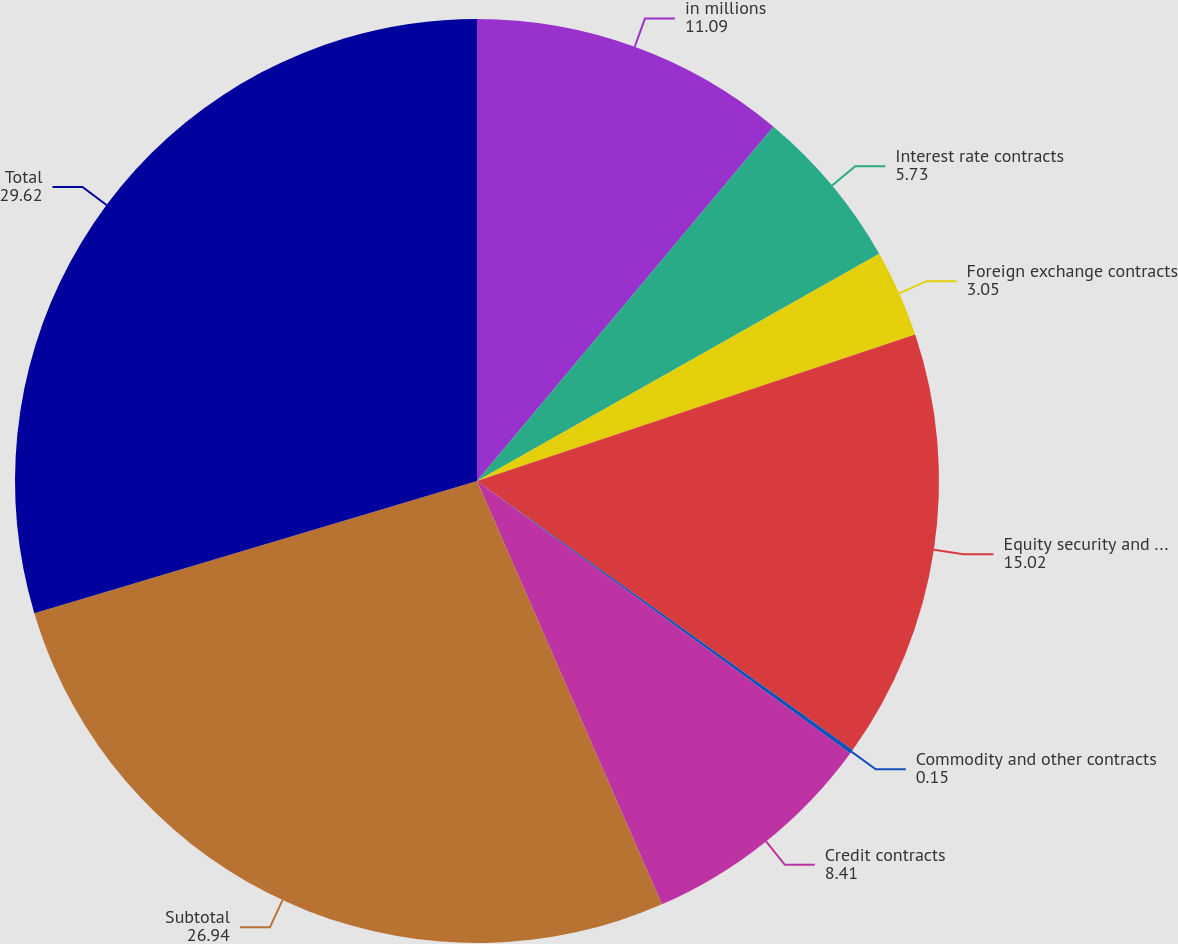Convert chart. <chart><loc_0><loc_0><loc_500><loc_500><pie_chart><fcel>in millions<fcel>Interest rate contracts<fcel>Foreign exchange contracts<fcel>Equity security and index<fcel>Commodity and other contracts<fcel>Credit contracts<fcel>Subtotal<fcel>Total<nl><fcel>11.09%<fcel>5.73%<fcel>3.05%<fcel>15.02%<fcel>0.15%<fcel>8.41%<fcel>26.94%<fcel>29.62%<nl></chart> 